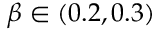<formula> <loc_0><loc_0><loc_500><loc_500>\beta \in ( 0 . 2 , 0 . 3 )</formula> 